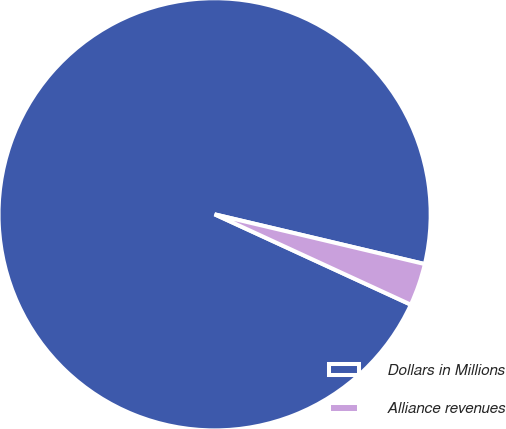<chart> <loc_0><loc_0><loc_500><loc_500><pie_chart><fcel>Dollars in Millions<fcel>Alliance revenues<nl><fcel>96.83%<fcel>3.17%<nl></chart> 